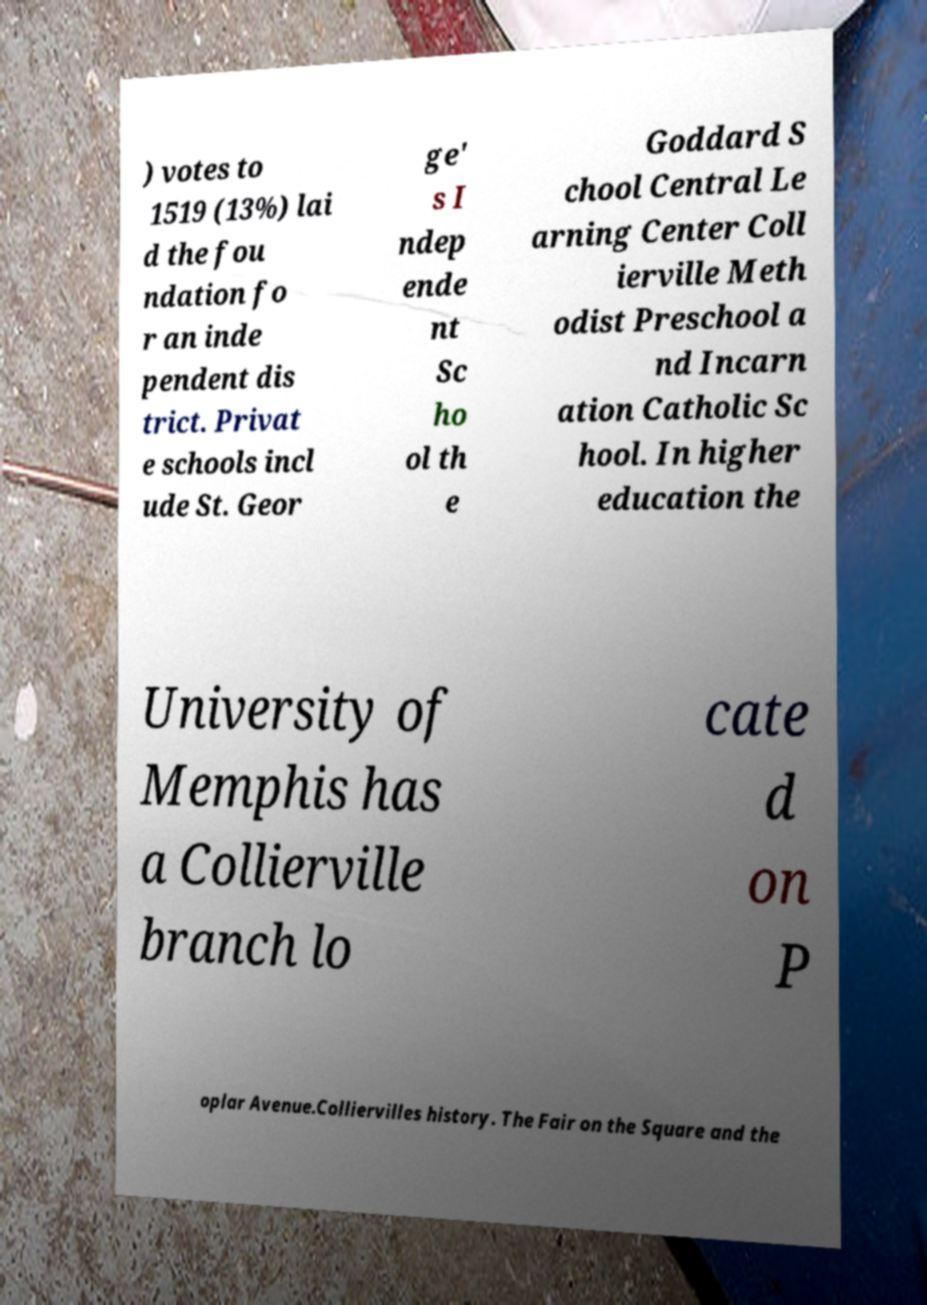Could you assist in decoding the text presented in this image and type it out clearly? ) votes to 1519 (13%) lai d the fou ndation fo r an inde pendent dis trict. Privat e schools incl ude St. Geor ge' s I ndep ende nt Sc ho ol th e Goddard S chool Central Le arning Center Coll ierville Meth odist Preschool a nd Incarn ation Catholic Sc hool. In higher education the University of Memphis has a Collierville branch lo cate d on P oplar Avenue.Colliervilles history. The Fair on the Square and the 